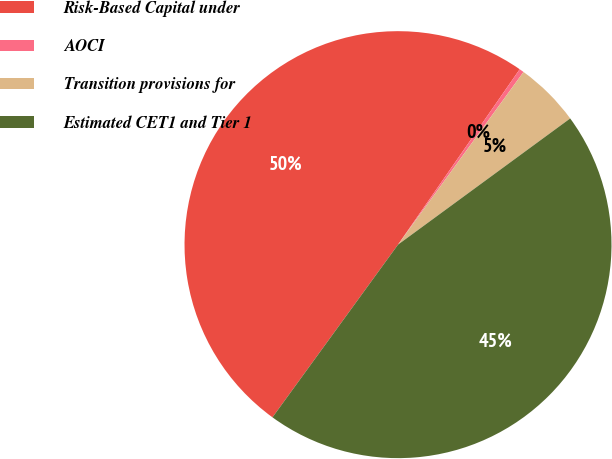Convert chart to OTSL. <chart><loc_0><loc_0><loc_500><loc_500><pie_chart><fcel>Risk-Based Capital under<fcel>AOCI<fcel>Transition provisions for<fcel>Estimated CET1 and Tier 1<nl><fcel>49.65%<fcel>0.35%<fcel>4.93%<fcel>45.07%<nl></chart> 